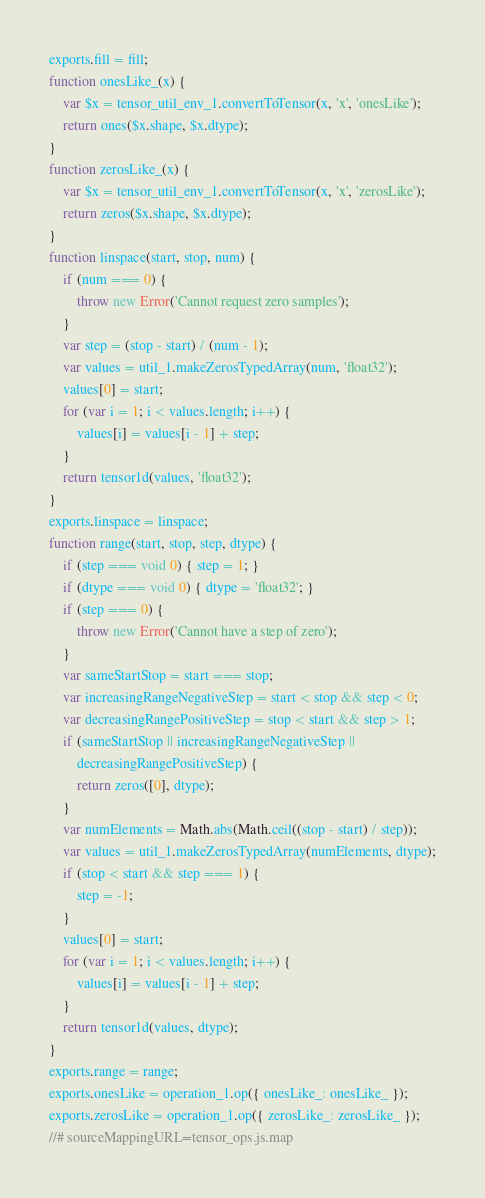Convert code to text. <code><loc_0><loc_0><loc_500><loc_500><_JavaScript_>exports.fill = fill;
function onesLike_(x) {
    var $x = tensor_util_env_1.convertToTensor(x, 'x', 'onesLike');
    return ones($x.shape, $x.dtype);
}
function zerosLike_(x) {
    var $x = tensor_util_env_1.convertToTensor(x, 'x', 'zerosLike');
    return zeros($x.shape, $x.dtype);
}
function linspace(start, stop, num) {
    if (num === 0) {
        throw new Error('Cannot request zero samples');
    }
    var step = (stop - start) / (num - 1);
    var values = util_1.makeZerosTypedArray(num, 'float32');
    values[0] = start;
    for (var i = 1; i < values.length; i++) {
        values[i] = values[i - 1] + step;
    }
    return tensor1d(values, 'float32');
}
exports.linspace = linspace;
function range(start, stop, step, dtype) {
    if (step === void 0) { step = 1; }
    if (dtype === void 0) { dtype = 'float32'; }
    if (step === 0) {
        throw new Error('Cannot have a step of zero');
    }
    var sameStartStop = start === stop;
    var increasingRangeNegativeStep = start < stop && step < 0;
    var decreasingRangePositiveStep = stop < start && step > 1;
    if (sameStartStop || increasingRangeNegativeStep ||
        decreasingRangePositiveStep) {
        return zeros([0], dtype);
    }
    var numElements = Math.abs(Math.ceil((stop - start) / step));
    var values = util_1.makeZerosTypedArray(numElements, dtype);
    if (stop < start && step === 1) {
        step = -1;
    }
    values[0] = start;
    for (var i = 1; i < values.length; i++) {
        values[i] = values[i - 1] + step;
    }
    return tensor1d(values, dtype);
}
exports.range = range;
exports.onesLike = operation_1.op({ onesLike_: onesLike_ });
exports.zerosLike = operation_1.op({ zerosLike_: zerosLike_ });
//# sourceMappingURL=tensor_ops.js.map</code> 